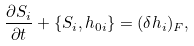<formula> <loc_0><loc_0><loc_500><loc_500>\frac { \partial S _ { i } } { \partial t } + \{ S _ { i } , h _ { 0 i } \} = ( \delta h _ { i } ) _ { F } ,</formula> 